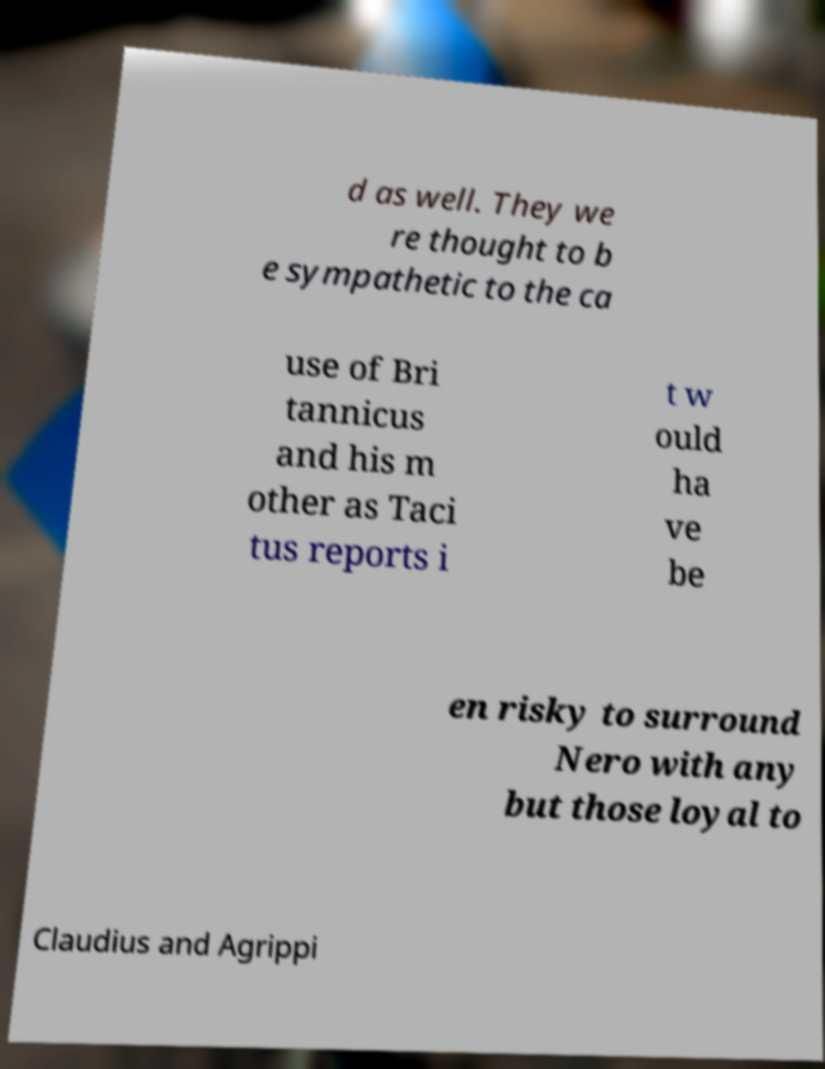Please read and relay the text visible in this image. What does it say? d as well. They we re thought to b e sympathetic to the ca use of Bri tannicus and his m other as Taci tus reports i t w ould ha ve be en risky to surround Nero with any but those loyal to Claudius and Agrippi 